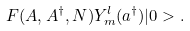<formula> <loc_0><loc_0><loc_500><loc_500>F ( A , A ^ { \dag } , N ) Y ^ { l } _ { m } ( a ^ { \dag } ) | 0 > .</formula> 